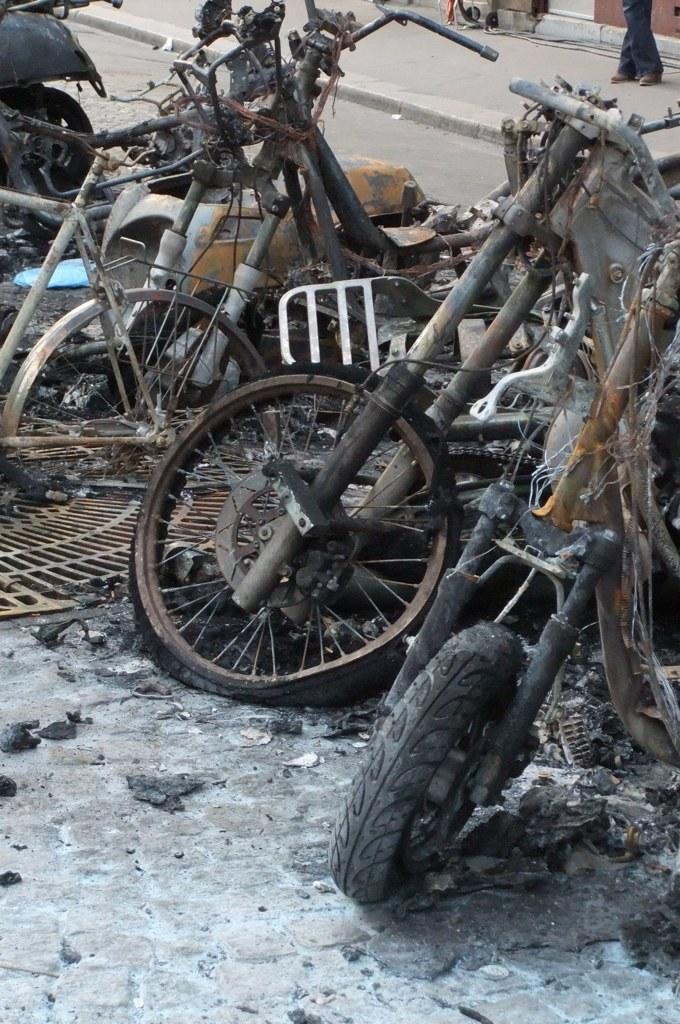Could you give a brief overview of what you see in this image? In this image, we can see motorcycle scrap. There is bicycle on the left side of the image. There is a footpath at the top of the image. There are person legs in the top right of the image. 